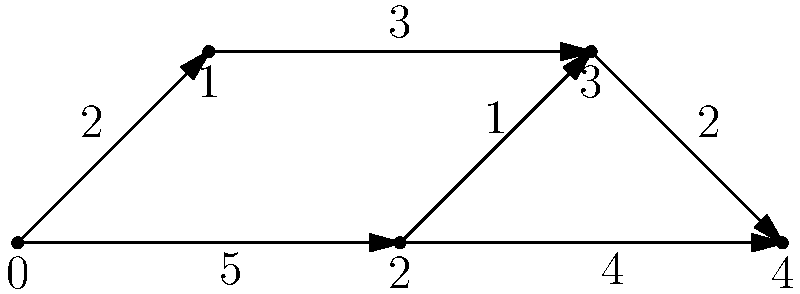In the network diagram above, each number represents the time (in minutes) it takes to travel between two connected points. What is the shortest time required to travel from point 0 to point 4? Let's approach this step-by-step:

1) First, we need to identify all possible paths from point 0 to point 4:
   Path 1: 0 → 1 → 3 → 4
   Path 2: 0 → 2 → 3 → 4
   Path 3: 0 → 2 → 4

2) Now, let's calculate the total time for each path:
   Path 1: 0 → 1 (2 min) → 3 (3 min) → 4 (2 min)
           Total: 2 + 3 + 2 = 7 minutes

   Path 2: 0 → 2 (5 min) → 3 (1 min) → 4 (2 min)
           Total: 5 + 1 + 2 = 8 minutes

   Path 3: 0 → 2 (5 min) → 4 (4 min)
           Total: 5 + 4 = 9 minutes

3) The shortest path is the one with the least total time. In this case, it's Path 1, which takes 7 minutes.

Therefore, the shortest time required to travel from point 0 to point 4 is 7 minutes.
Answer: 7 minutes 